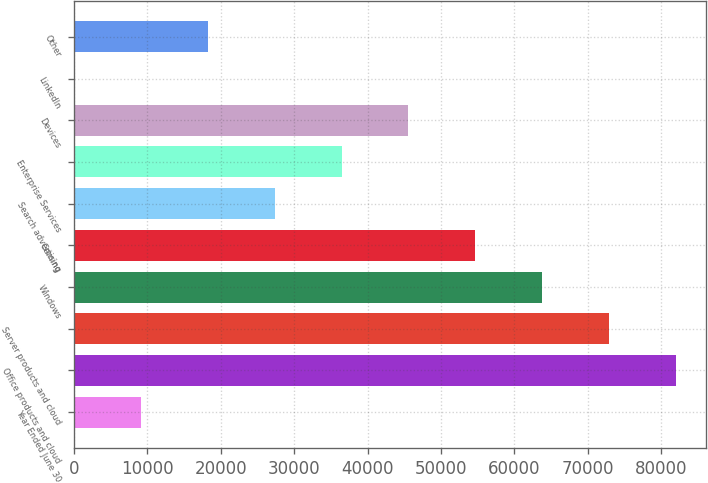<chart> <loc_0><loc_0><loc_500><loc_500><bar_chart><fcel>Year Ended June 30<fcel>Office products and cloud<fcel>Server products and cloud<fcel>Windows<fcel>Gaming<fcel>Search advertising<fcel>Enterprise Services<fcel>Devices<fcel>LinkedIn<fcel>Other<nl><fcel>9119.31<fcel>82039.1<fcel>72924.1<fcel>63809.1<fcel>54694.2<fcel>27349.2<fcel>36464.2<fcel>45579.2<fcel>4.34<fcel>18234.3<nl></chart> 